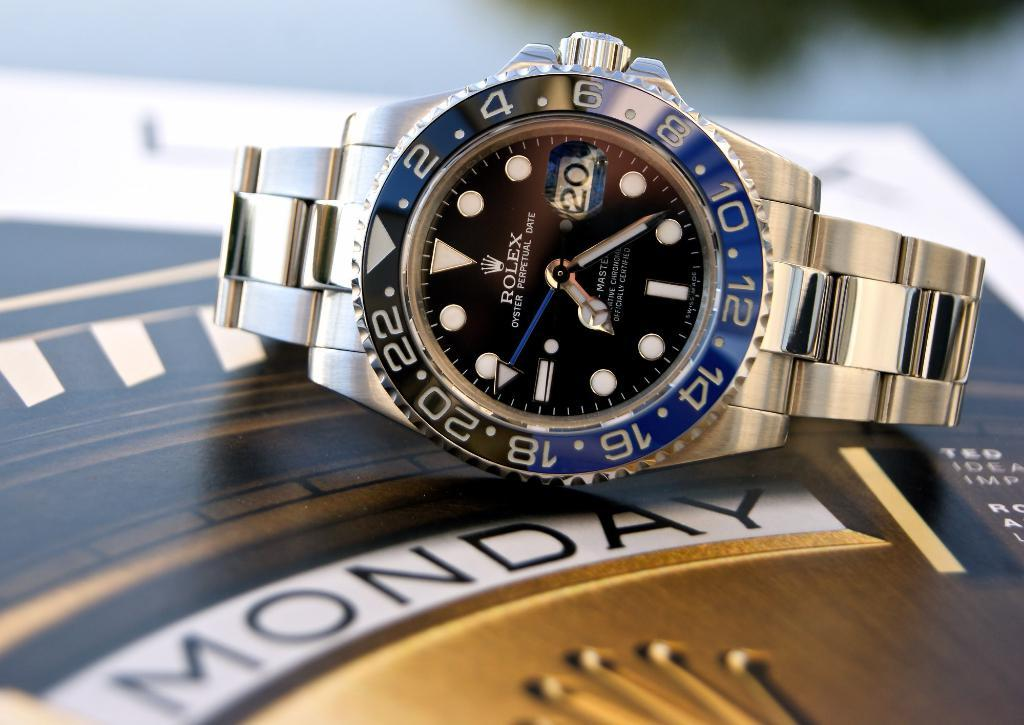<image>
Summarize the visual content of the image. a Rolex watch laying on a background saying Monday 